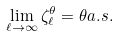Convert formula to latex. <formula><loc_0><loc_0><loc_500><loc_500>\lim _ { \ell \to \infty } \zeta _ { \ell } ^ { \theta } = \theta a . s .</formula> 